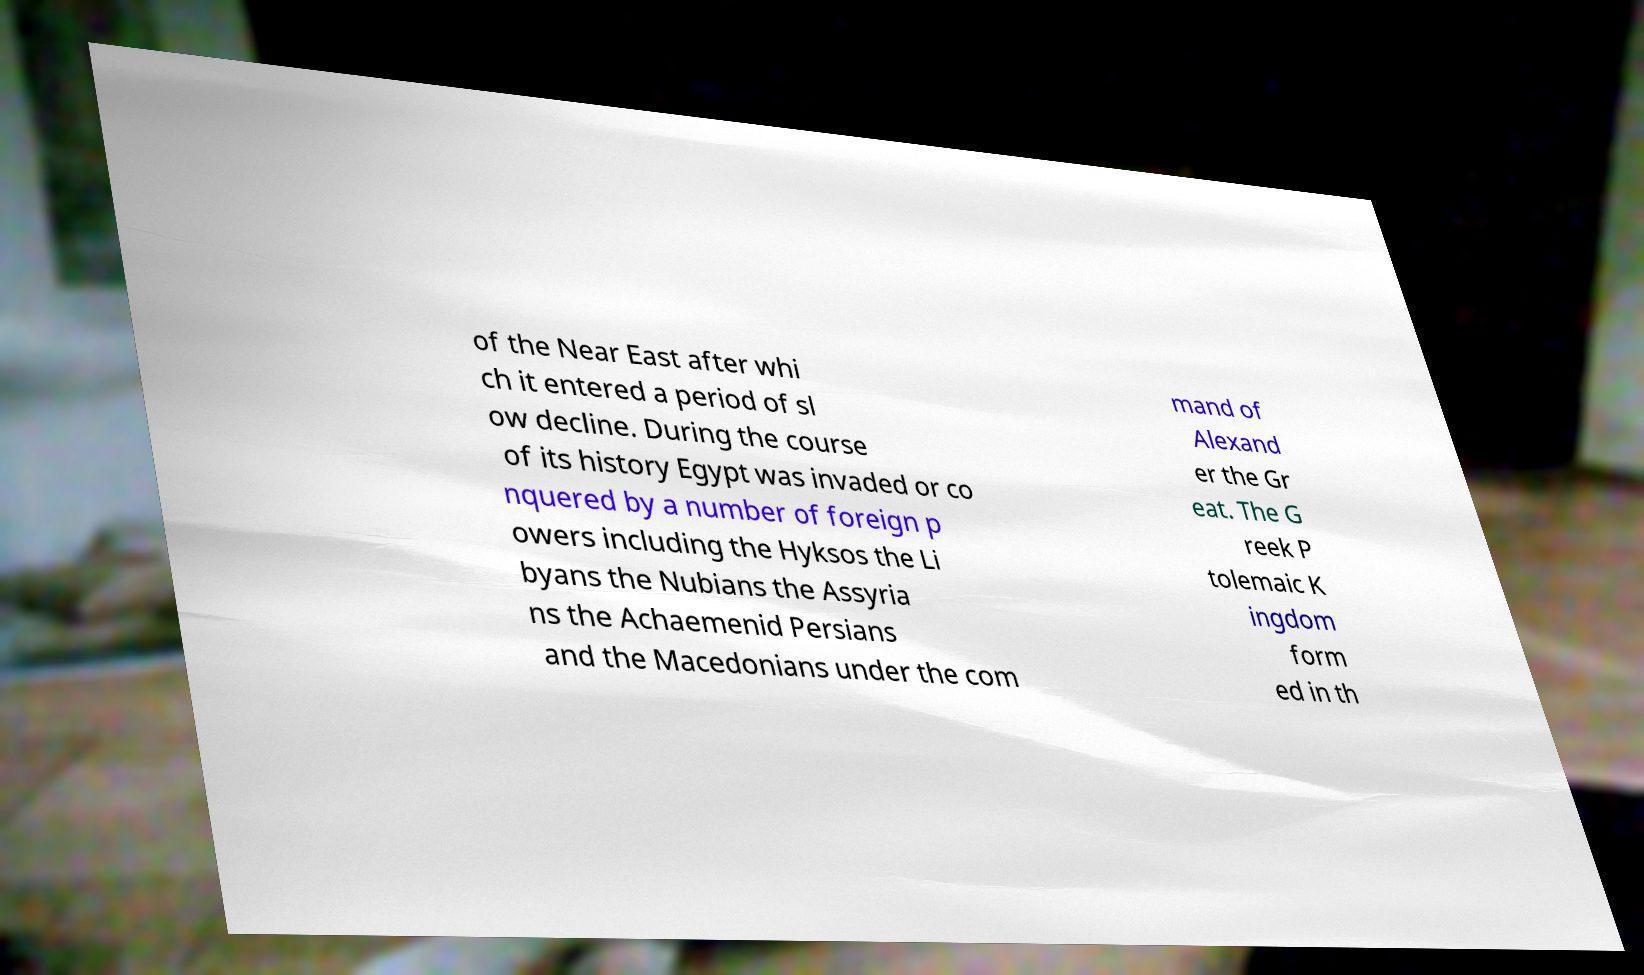What messages or text are displayed in this image? I need them in a readable, typed format. of the Near East after whi ch it entered a period of sl ow decline. During the course of its history Egypt was invaded or co nquered by a number of foreign p owers including the Hyksos the Li byans the Nubians the Assyria ns the Achaemenid Persians and the Macedonians under the com mand of Alexand er the Gr eat. The G reek P tolemaic K ingdom form ed in th 